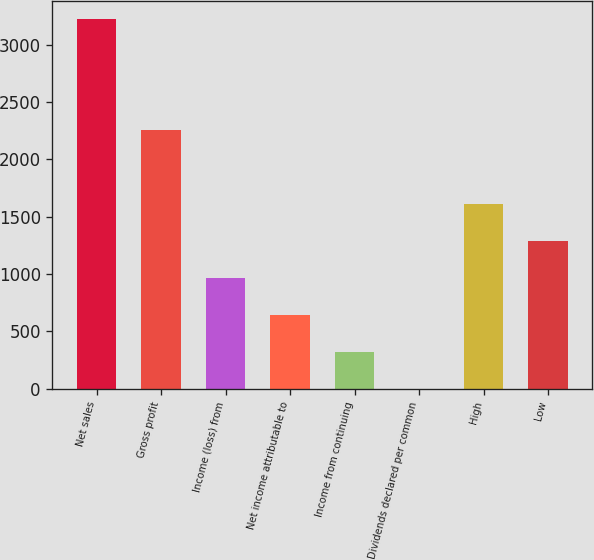Convert chart. <chart><loc_0><loc_0><loc_500><loc_500><bar_chart><fcel>Net sales<fcel>Gross profit<fcel>Income (loss) from<fcel>Net income attributable to<fcel>Income from continuing<fcel>Dividends declared per common<fcel>High<fcel>Low<nl><fcel>3224.3<fcel>2257.06<fcel>967.42<fcel>645.01<fcel>322.6<fcel>0.19<fcel>1612.24<fcel>1289.83<nl></chart> 